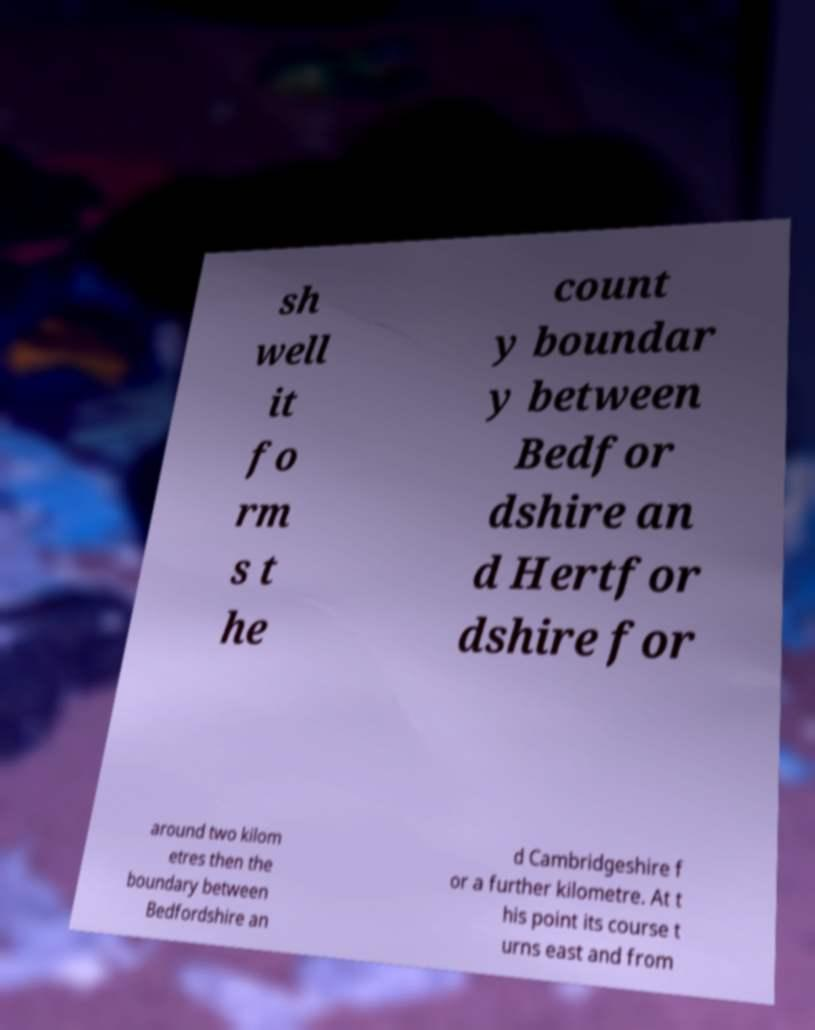I need the written content from this picture converted into text. Can you do that? sh well it fo rm s t he count y boundar y between Bedfor dshire an d Hertfor dshire for around two kilom etres then the boundary between Bedfordshire an d Cambridgeshire f or a further kilometre. At t his point its course t urns east and from 